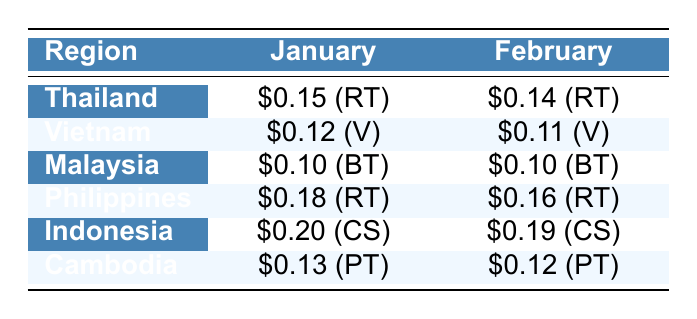What is the transportation cost per kilometer for Thailand in January? The table indicates that the transportation cost per kilometer for Thailand in January is $0.15.
Answer: $0.15 What type of vehicle was used for transporting organic produce from Vietnam in February? According to the table, a van was used for transportation from Vietnam in February.
Answer: Van Which region had the highest transportation cost in January? The highest transportation cost in January is $400 for Indonesia, as shown in the table.
Answer: Indonesia What is the average cost per kilometer for Malaysia in both January and February? The costs for Malaysia are $0.10 for both January and February, so the average is (0.10 + 0.10) / 2 = $0.10.
Answer: $0.10 Did the transportation cost per kilometer decrease for Vietnam from January to February? The cost for Vietnam in January is $0.12 and in February it is $0.11, which indicates a decrease.
Answer: Yes Which region has the lowest total transportation cost in January? The total transportation cost in January for Malaysia is $200, which is the lowest compared to other regions in the same month.
Answer: Malaysia What is the difference in transportation costs between Thailand and the Philippines in February? Thailand's transportation cost in February is $280, whereas the Philippines' is $320. The difference is $320 - $280 = $40.
Answer: $40 Identify the vehicle type used for transporting organic produce in Cambodia in January. The table shows that a pickup truck was used for transportation in Cambodia in January.
Answer: Pickup Truck What are the total transportation costs for both January and February in Thailand? The total costs are $300 for January and $280 for February, summing them gives $300 + $280 = $580.
Answer: $580 Is the cost per kilometer higher for Indonesia or the Philippines in January? Indonesia's cost per kilometer in January is $0.20, while the Philippines' cost is $0.18, making Indonesia higher.
Answer: Indonesia 